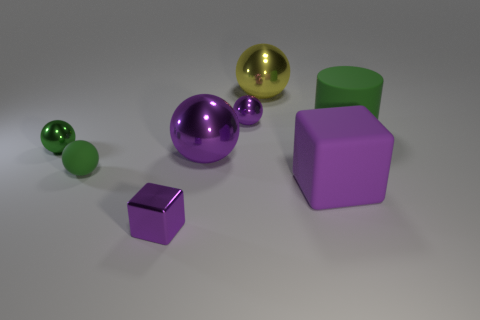There is another sphere that is the same color as the small matte ball; what is it made of?
Offer a terse response. Metal. How many spheres are either big yellow shiny things or small purple things?
Your answer should be very brief. 2. Is there another large rubber thing that has the same shape as the large green rubber thing?
Keep it short and to the point. No. How many other objects are the same color as the cylinder?
Offer a very short reply. 2. Is the number of green matte cylinders on the left side of the small purple ball less than the number of small green cylinders?
Ensure brevity in your answer.  No. What number of red metal cubes are there?
Offer a very short reply. 0. What number of large yellow spheres have the same material as the large yellow object?
Offer a very short reply. 0. How many things are either shiny things that are on the left side of the tiny purple sphere or tiny red metal cylinders?
Keep it short and to the point. 3. Are there fewer small blocks to the left of the small green rubber sphere than small purple blocks right of the yellow sphere?
Offer a very short reply. No. There is a big green cylinder; are there any purple objects in front of it?
Your answer should be compact. Yes. 